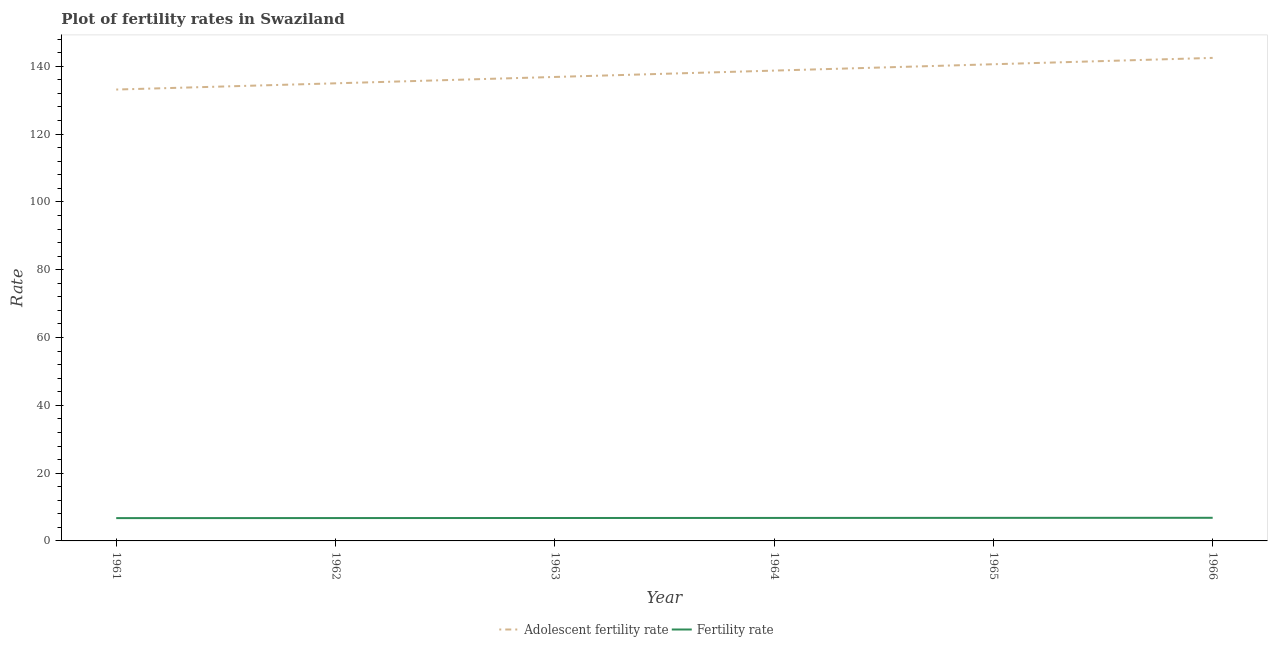How many different coloured lines are there?
Your answer should be very brief. 2. Is the number of lines equal to the number of legend labels?
Ensure brevity in your answer.  Yes. What is the adolescent fertility rate in 1961?
Keep it short and to the point. 133.15. Across all years, what is the maximum fertility rate?
Your response must be concise. 6.82. Across all years, what is the minimum adolescent fertility rate?
Provide a succinct answer. 133.15. In which year was the fertility rate maximum?
Offer a very short reply. 1966. What is the total adolescent fertility rate in the graph?
Provide a succinct answer. 826.84. What is the difference between the fertility rate in 1962 and that in 1963?
Provide a succinct answer. -0.02. What is the difference between the adolescent fertility rate in 1961 and the fertility rate in 1964?
Offer a very short reply. 126.37. What is the average adolescent fertility rate per year?
Keep it short and to the point. 137.81. In the year 1961, what is the difference between the adolescent fertility rate and fertility rate?
Provide a succinct answer. 126.42. What is the ratio of the fertility rate in 1965 to that in 1966?
Ensure brevity in your answer.  1. Is the fertility rate in 1961 less than that in 1965?
Your answer should be compact. Yes. What is the difference between the highest and the second highest fertility rate?
Provide a succinct answer. 0.02. What is the difference between the highest and the lowest fertility rate?
Your answer should be compact. 0.09. In how many years, is the adolescent fertility rate greater than the average adolescent fertility rate taken over all years?
Make the answer very short. 3. Is the sum of the fertility rate in 1961 and 1963 greater than the maximum adolescent fertility rate across all years?
Offer a very short reply. No. Does the adolescent fertility rate monotonically increase over the years?
Your answer should be compact. Yes. Is the fertility rate strictly less than the adolescent fertility rate over the years?
Ensure brevity in your answer.  Yes. How many years are there in the graph?
Your response must be concise. 6. What is the difference between two consecutive major ticks on the Y-axis?
Ensure brevity in your answer.  20. Does the graph contain grids?
Offer a very short reply. No. How many legend labels are there?
Ensure brevity in your answer.  2. How are the legend labels stacked?
Keep it short and to the point. Horizontal. What is the title of the graph?
Make the answer very short. Plot of fertility rates in Swaziland. What is the label or title of the Y-axis?
Ensure brevity in your answer.  Rate. What is the Rate in Adolescent fertility rate in 1961?
Offer a very short reply. 133.15. What is the Rate of Fertility rate in 1961?
Keep it short and to the point. 6.73. What is the Rate in Adolescent fertility rate in 1962?
Give a very brief answer. 134.99. What is the Rate of Fertility rate in 1962?
Offer a very short reply. 6.75. What is the Rate of Adolescent fertility rate in 1963?
Provide a succinct answer. 136.86. What is the Rate of Fertility rate in 1963?
Your answer should be compact. 6.76. What is the Rate in Adolescent fertility rate in 1964?
Provide a succinct answer. 138.74. What is the Rate in Fertility rate in 1964?
Offer a very short reply. 6.78. What is the Rate in Adolescent fertility rate in 1965?
Make the answer very short. 140.61. What is the Rate of Fertility rate in 1965?
Provide a short and direct response. 6.8. What is the Rate of Adolescent fertility rate in 1966?
Provide a succinct answer. 142.49. What is the Rate of Fertility rate in 1966?
Your response must be concise. 6.82. Across all years, what is the maximum Rate in Adolescent fertility rate?
Your answer should be compact. 142.49. Across all years, what is the maximum Rate in Fertility rate?
Your answer should be compact. 6.82. Across all years, what is the minimum Rate in Adolescent fertility rate?
Your answer should be compact. 133.15. Across all years, what is the minimum Rate of Fertility rate?
Offer a terse response. 6.73. What is the total Rate in Adolescent fertility rate in the graph?
Offer a terse response. 826.84. What is the total Rate of Fertility rate in the graph?
Your answer should be compact. 40.64. What is the difference between the Rate in Adolescent fertility rate in 1961 and that in 1962?
Your answer should be compact. -1.84. What is the difference between the Rate of Fertility rate in 1961 and that in 1962?
Ensure brevity in your answer.  -0.01. What is the difference between the Rate of Adolescent fertility rate in 1961 and that in 1963?
Your response must be concise. -3.71. What is the difference between the Rate of Fertility rate in 1961 and that in 1963?
Give a very brief answer. -0.03. What is the difference between the Rate in Adolescent fertility rate in 1961 and that in 1964?
Your answer should be very brief. -5.59. What is the difference between the Rate of Fertility rate in 1961 and that in 1964?
Make the answer very short. -0.05. What is the difference between the Rate of Adolescent fertility rate in 1961 and that in 1965?
Make the answer very short. -7.46. What is the difference between the Rate in Fertility rate in 1961 and that in 1965?
Provide a succinct answer. -0.07. What is the difference between the Rate of Adolescent fertility rate in 1961 and that in 1966?
Offer a very short reply. -9.34. What is the difference between the Rate of Fertility rate in 1961 and that in 1966?
Ensure brevity in your answer.  -0.09. What is the difference between the Rate of Adolescent fertility rate in 1962 and that in 1963?
Give a very brief answer. -1.88. What is the difference between the Rate in Fertility rate in 1962 and that in 1963?
Make the answer very short. -0.02. What is the difference between the Rate of Adolescent fertility rate in 1962 and that in 1964?
Your response must be concise. -3.75. What is the difference between the Rate in Fertility rate in 1962 and that in 1964?
Provide a succinct answer. -0.04. What is the difference between the Rate of Adolescent fertility rate in 1962 and that in 1965?
Ensure brevity in your answer.  -5.63. What is the difference between the Rate of Fertility rate in 1962 and that in 1965?
Provide a short and direct response. -0.06. What is the difference between the Rate in Adolescent fertility rate in 1962 and that in 1966?
Make the answer very short. -7.5. What is the difference between the Rate in Fertility rate in 1962 and that in 1966?
Provide a short and direct response. -0.08. What is the difference between the Rate in Adolescent fertility rate in 1963 and that in 1964?
Offer a very short reply. -1.88. What is the difference between the Rate in Fertility rate in 1963 and that in 1964?
Provide a short and direct response. -0.02. What is the difference between the Rate of Adolescent fertility rate in 1963 and that in 1965?
Keep it short and to the point. -3.75. What is the difference between the Rate in Fertility rate in 1963 and that in 1965?
Your answer should be compact. -0.04. What is the difference between the Rate in Adolescent fertility rate in 1963 and that in 1966?
Ensure brevity in your answer.  -5.63. What is the difference between the Rate of Fertility rate in 1963 and that in 1966?
Provide a short and direct response. -0.06. What is the difference between the Rate in Adolescent fertility rate in 1964 and that in 1965?
Your answer should be compact. -1.88. What is the difference between the Rate in Fertility rate in 1964 and that in 1965?
Your response must be concise. -0.02. What is the difference between the Rate of Adolescent fertility rate in 1964 and that in 1966?
Provide a succinct answer. -3.75. What is the difference between the Rate of Fertility rate in 1964 and that in 1966?
Provide a short and direct response. -0.04. What is the difference between the Rate of Adolescent fertility rate in 1965 and that in 1966?
Keep it short and to the point. -1.88. What is the difference between the Rate in Fertility rate in 1965 and that in 1966?
Keep it short and to the point. -0.02. What is the difference between the Rate of Adolescent fertility rate in 1961 and the Rate of Fertility rate in 1962?
Keep it short and to the point. 126.4. What is the difference between the Rate in Adolescent fertility rate in 1961 and the Rate in Fertility rate in 1963?
Offer a very short reply. 126.39. What is the difference between the Rate of Adolescent fertility rate in 1961 and the Rate of Fertility rate in 1964?
Keep it short and to the point. 126.37. What is the difference between the Rate of Adolescent fertility rate in 1961 and the Rate of Fertility rate in 1965?
Provide a succinct answer. 126.35. What is the difference between the Rate in Adolescent fertility rate in 1961 and the Rate in Fertility rate in 1966?
Your answer should be very brief. 126.33. What is the difference between the Rate in Adolescent fertility rate in 1962 and the Rate in Fertility rate in 1963?
Give a very brief answer. 128.22. What is the difference between the Rate of Adolescent fertility rate in 1962 and the Rate of Fertility rate in 1964?
Keep it short and to the point. 128.21. What is the difference between the Rate in Adolescent fertility rate in 1962 and the Rate in Fertility rate in 1965?
Keep it short and to the point. 128.19. What is the difference between the Rate in Adolescent fertility rate in 1962 and the Rate in Fertility rate in 1966?
Offer a very short reply. 128.16. What is the difference between the Rate in Adolescent fertility rate in 1963 and the Rate in Fertility rate in 1964?
Your answer should be compact. 130.08. What is the difference between the Rate in Adolescent fertility rate in 1963 and the Rate in Fertility rate in 1965?
Ensure brevity in your answer.  130.06. What is the difference between the Rate in Adolescent fertility rate in 1963 and the Rate in Fertility rate in 1966?
Keep it short and to the point. 130.04. What is the difference between the Rate of Adolescent fertility rate in 1964 and the Rate of Fertility rate in 1965?
Your response must be concise. 131.94. What is the difference between the Rate in Adolescent fertility rate in 1964 and the Rate in Fertility rate in 1966?
Provide a succinct answer. 131.92. What is the difference between the Rate of Adolescent fertility rate in 1965 and the Rate of Fertility rate in 1966?
Ensure brevity in your answer.  133.79. What is the average Rate of Adolescent fertility rate per year?
Give a very brief answer. 137.81. What is the average Rate of Fertility rate per year?
Your response must be concise. 6.77. In the year 1961, what is the difference between the Rate in Adolescent fertility rate and Rate in Fertility rate?
Keep it short and to the point. 126.42. In the year 1962, what is the difference between the Rate of Adolescent fertility rate and Rate of Fertility rate?
Offer a terse response. 128.24. In the year 1963, what is the difference between the Rate in Adolescent fertility rate and Rate in Fertility rate?
Keep it short and to the point. 130.1. In the year 1964, what is the difference between the Rate of Adolescent fertility rate and Rate of Fertility rate?
Keep it short and to the point. 131.96. In the year 1965, what is the difference between the Rate in Adolescent fertility rate and Rate in Fertility rate?
Ensure brevity in your answer.  133.81. In the year 1966, what is the difference between the Rate of Adolescent fertility rate and Rate of Fertility rate?
Offer a terse response. 135.67. What is the ratio of the Rate of Adolescent fertility rate in 1961 to that in 1962?
Provide a succinct answer. 0.99. What is the ratio of the Rate in Fertility rate in 1961 to that in 1962?
Offer a very short reply. 1. What is the ratio of the Rate of Adolescent fertility rate in 1961 to that in 1963?
Provide a short and direct response. 0.97. What is the ratio of the Rate in Fertility rate in 1961 to that in 1963?
Keep it short and to the point. 1. What is the ratio of the Rate in Adolescent fertility rate in 1961 to that in 1964?
Offer a terse response. 0.96. What is the ratio of the Rate of Fertility rate in 1961 to that in 1964?
Make the answer very short. 0.99. What is the ratio of the Rate in Adolescent fertility rate in 1961 to that in 1965?
Offer a very short reply. 0.95. What is the ratio of the Rate in Adolescent fertility rate in 1961 to that in 1966?
Make the answer very short. 0.93. What is the ratio of the Rate of Fertility rate in 1961 to that in 1966?
Provide a short and direct response. 0.99. What is the ratio of the Rate of Adolescent fertility rate in 1962 to that in 1963?
Keep it short and to the point. 0.99. What is the ratio of the Rate of Fertility rate in 1962 to that in 1963?
Your answer should be compact. 1. What is the ratio of the Rate of Adolescent fertility rate in 1962 to that in 1964?
Your answer should be very brief. 0.97. What is the ratio of the Rate in Fertility rate in 1962 to that in 1964?
Your response must be concise. 0.99. What is the ratio of the Rate of Fertility rate in 1962 to that in 1965?
Make the answer very short. 0.99. What is the ratio of the Rate of Adolescent fertility rate in 1962 to that in 1966?
Your answer should be very brief. 0.95. What is the ratio of the Rate in Fertility rate in 1962 to that in 1966?
Your response must be concise. 0.99. What is the ratio of the Rate in Adolescent fertility rate in 1963 to that in 1964?
Your response must be concise. 0.99. What is the ratio of the Rate in Fertility rate in 1963 to that in 1964?
Offer a very short reply. 1. What is the ratio of the Rate of Adolescent fertility rate in 1963 to that in 1965?
Offer a terse response. 0.97. What is the ratio of the Rate of Fertility rate in 1963 to that in 1965?
Keep it short and to the point. 0.99. What is the ratio of the Rate in Adolescent fertility rate in 1963 to that in 1966?
Provide a succinct answer. 0.96. What is the ratio of the Rate in Adolescent fertility rate in 1964 to that in 1965?
Make the answer very short. 0.99. What is the ratio of the Rate of Adolescent fertility rate in 1964 to that in 1966?
Provide a short and direct response. 0.97. What is the ratio of the Rate in Adolescent fertility rate in 1965 to that in 1966?
Offer a very short reply. 0.99. What is the difference between the highest and the second highest Rate in Adolescent fertility rate?
Your response must be concise. 1.88. What is the difference between the highest and the lowest Rate in Adolescent fertility rate?
Give a very brief answer. 9.34. What is the difference between the highest and the lowest Rate in Fertility rate?
Ensure brevity in your answer.  0.09. 